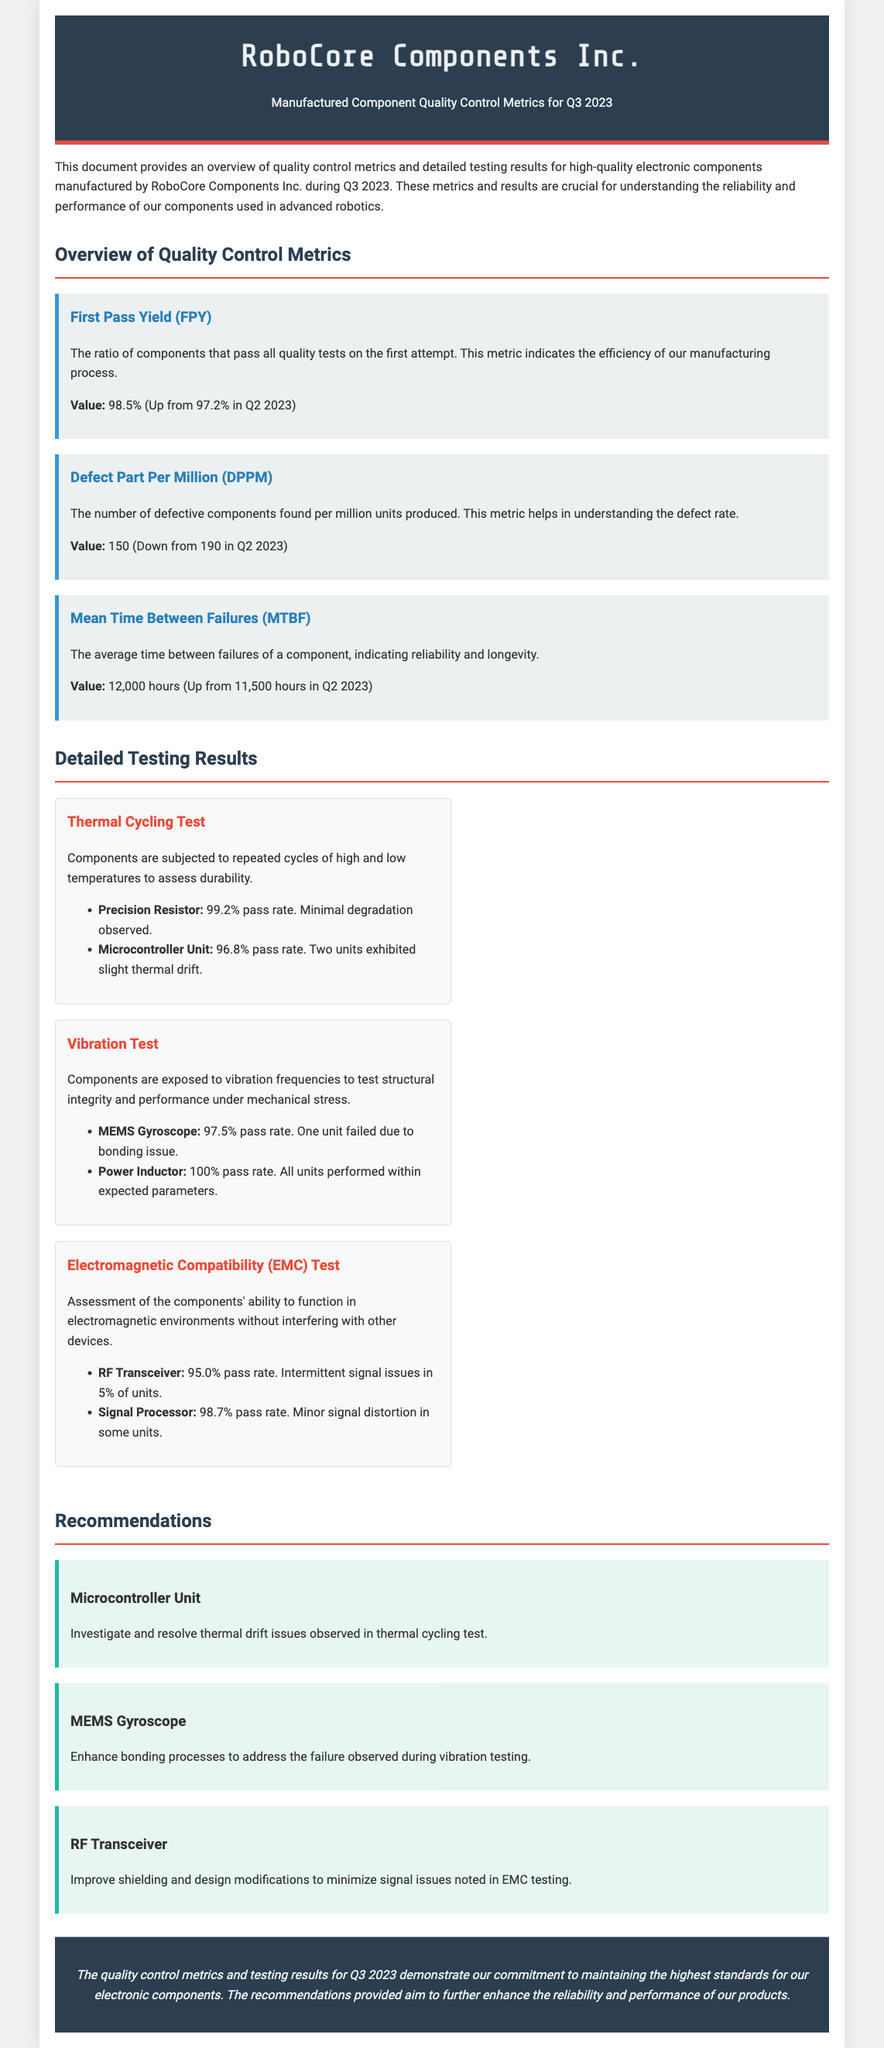what is the First Pass Yield for Q3 2023? The First Pass Yield is the ratio of components that pass all quality tests on the first attempt, listed in the document as 98.5%.
Answer: 98.5% what was the Defect Part Per Million in Q2 2023? The Defect Part Per Million in Q2 2023 is mentioned as 190, which allows comparison with Q3 2023's value.
Answer: 190 what is the Mean Time Between Failures reported for Q3 2023? The Mean Time Between Failures for Q3 2023 is stated as 12,000 hours in the document.
Answer: 12,000 hours which component had a pass rate of 100% in the Vibration Test? The document specifies that the Power Inductor achieved a 100% pass rate in the Vibration Test.
Answer: Power Inductor what is the recommendation for the Microcontroller Unit? The recommendation for the Microcontroller Unit is to investigate and resolve thermal drift issues.
Answer: Investigate and resolve thermal drift issues how many units exhibited slight thermal drift in the Microcontroller Unit? The document mentions that two units exhibited slight thermal drift in the Microcontroller Unit during testing.
Answer: Two units what is the pass rate for the RF Transceiver in the EMC Test? The RF Transceiver has a pass rate of 95.0% in the EMC Test, as indicated in the results.
Answer: 95.0% what is the primary focus of the Q3 2023 Quality Control Report? The primary focus is on providing an overview of quality control metrics and detailed testing results for high-quality electronic components.
Answer: Overview of quality control metrics and detailed testing results which two components need improvements based on the recommendations provided? The components that need improvements are the Microcontroller Unit and MEMS Gyroscope based on the recommendations given in the document.
Answer: Microcontroller Unit and MEMS Gyroscope 